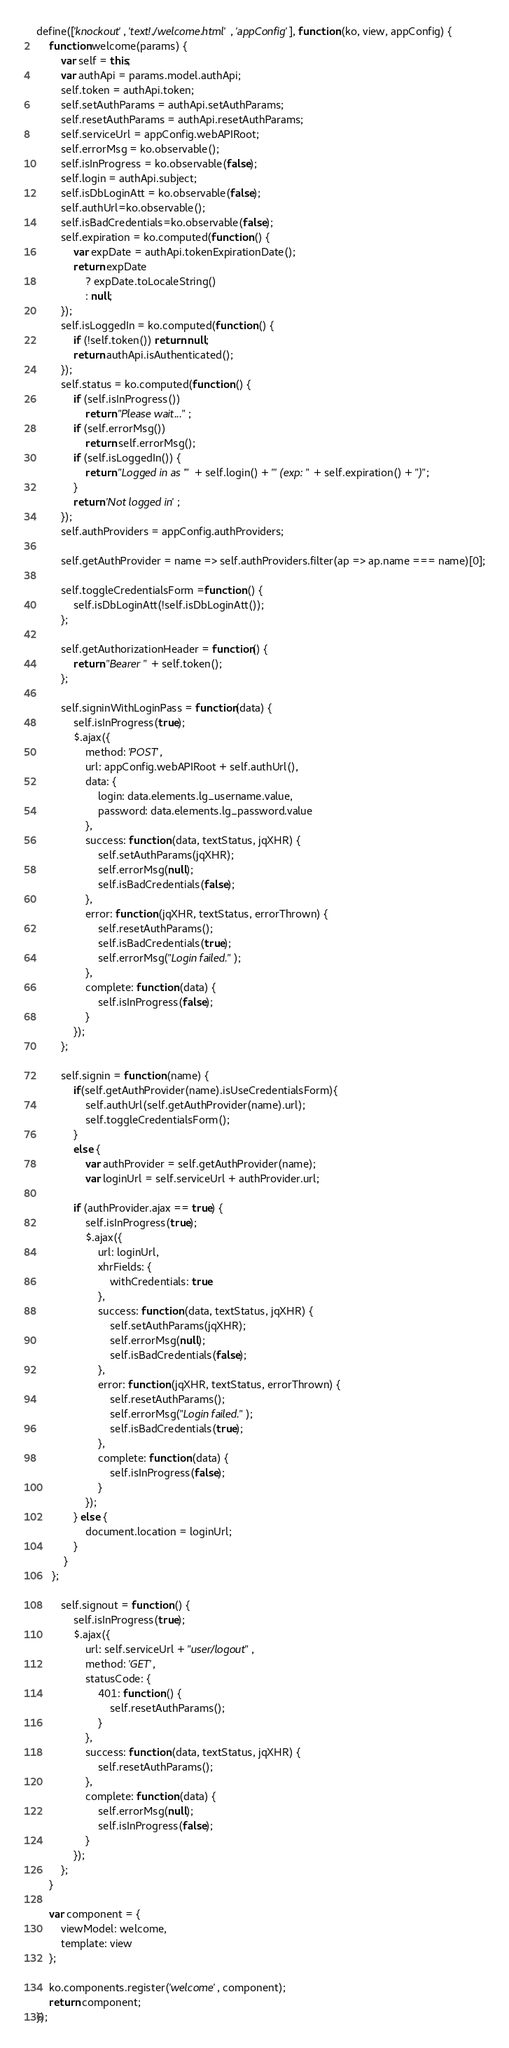Convert code to text. <code><loc_0><loc_0><loc_500><loc_500><_JavaScript_>define(['knockout', 'text!./welcome.html', 'appConfig'], function (ko, view, appConfig) {
    function welcome(params) {
        var self = this;
        var authApi = params.model.authApi;
        self.token = authApi.token;
        self.setAuthParams = authApi.setAuthParams;
        self.resetAuthParams = authApi.resetAuthParams;
        self.serviceUrl = appConfig.webAPIRoot;
        self.errorMsg = ko.observable();
        self.isInProgress = ko.observable(false);
        self.login = authApi.subject;
        self.isDbLoginAtt = ko.observable(false);
        self.authUrl=ko.observable();
        self.isBadCredentials=ko.observable(false);
        self.expiration = ko.computed(function () {
            var expDate = authApi.tokenExpirationDate();
            return expDate
                ? expDate.toLocaleString()
                : null;
        });
        self.isLoggedIn = ko.computed(function () {
            if (!self.token()) return null;
            return authApi.isAuthenticated();
        });
        self.status = ko.computed(function () {
            if (self.isInProgress())
                return "Please wait...";
            if (self.errorMsg())
                return self.errorMsg();
            if (self.isLoggedIn()) {
                return "Logged in as '" + self.login() + "' (exp: " + self.expiration() + ")";
            }
            return 'Not logged in';
        });
        self.authProviders = appConfig.authProviders;

        self.getAuthProvider = name => self.authProviders.filter(ap => ap.name === name)[0];

        self.toggleCredentialsForm =function () {
            self.isDbLoginAtt(!self.isDbLoginAtt());
        };

        self.getAuthorizationHeader = function() {
            return "Bearer " + self.token();
        };

        self.signinWithLoginPass = function(data) {
            self.isInProgress(true);
            $.ajax({
                method: 'POST',
                url: appConfig.webAPIRoot + self.authUrl(),
                data: {
                    login: data.elements.lg_username.value,
                    password: data.elements.lg_password.value
                },
                success: function (data, textStatus, jqXHR) {
                    self.setAuthParams(jqXHR);
                    self.errorMsg(null);
                    self.isBadCredentials(false);
                },
                error: function (jqXHR, textStatus, errorThrown) {
                    self.resetAuthParams();
                    self.isBadCredentials(true);
                    self.errorMsg("Login failed.");
                },
                complete: function (data) {
                    self.isInProgress(false);
                }
            });
        };

        self.signin = function (name) {
            if(self.getAuthProvider(name).isUseCredentialsForm){
                self.authUrl(self.getAuthProvider(name).url);
                self.toggleCredentialsForm();
            }
            else {
                var authProvider = self.getAuthProvider(name);
                var loginUrl = self.serviceUrl + authProvider.url;

            if (authProvider.ajax == true) {
                self.isInProgress(true);
                $.ajax({
                    url: loginUrl,
                    xhrFields: {
                        withCredentials: true
                    },
                    success: function (data, textStatus, jqXHR) {
                        self.setAuthParams(jqXHR);
                        self.errorMsg(null);
                        self.isBadCredentials(false);
                    },
                    error: function (jqXHR, textStatus, errorThrown) {
                        self.resetAuthParams();
                        self.errorMsg("Login failed.");
                        self.isBadCredentials(true);
                    },
                    complete: function (data) {
                        self.isInProgress(false);
                    }
                });
            } else {
                document.location = loginUrl;
            }
         }
     };

        self.signout = function () {
            self.isInProgress(true);
            $.ajax({
                url: self.serviceUrl + "user/logout",
                method: 'GET',
                statusCode: {
                    401: function () {
                        self.resetAuthParams();
                    }
                },
                success: function (data, textStatus, jqXHR) {
                    self.resetAuthParams();
                },
                complete: function (data) {
                    self.errorMsg(null);
                    self.isInProgress(false);
                }
            });
        };
    }

    var component = {
        viewModel: welcome,
        template: view
    };

    ko.components.register('welcome', component);
    return component;
});
</code> 